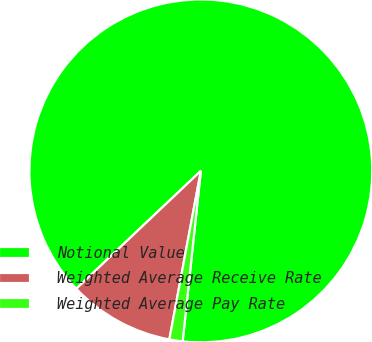<chart> <loc_0><loc_0><loc_500><loc_500><pie_chart><fcel>Notional Value<fcel>Weighted Average Receive Rate<fcel>Weighted Average Pay Rate<nl><fcel>88.75%<fcel>10.0%<fcel>1.25%<nl></chart> 